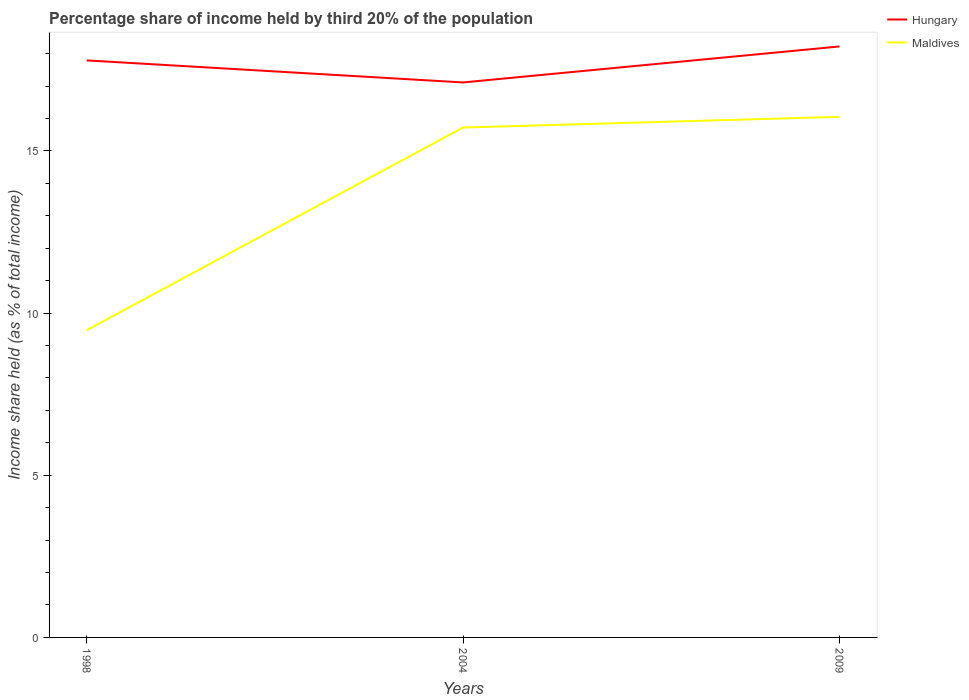How many different coloured lines are there?
Ensure brevity in your answer.  2. Does the line corresponding to Maldives intersect with the line corresponding to Hungary?
Make the answer very short. No. Across all years, what is the maximum share of income held by third 20% of the population in Maldives?
Make the answer very short. 9.47. In which year was the share of income held by third 20% of the population in Maldives maximum?
Keep it short and to the point. 1998. What is the total share of income held by third 20% of the population in Maldives in the graph?
Your answer should be very brief. -0.33. What is the difference between the highest and the second highest share of income held by third 20% of the population in Maldives?
Provide a succinct answer. 6.58. What is the difference between the highest and the lowest share of income held by third 20% of the population in Hungary?
Ensure brevity in your answer.  2. Is the share of income held by third 20% of the population in Hungary strictly greater than the share of income held by third 20% of the population in Maldives over the years?
Ensure brevity in your answer.  No. What is the difference between two consecutive major ticks on the Y-axis?
Offer a terse response. 5. Are the values on the major ticks of Y-axis written in scientific E-notation?
Make the answer very short. No. How many legend labels are there?
Offer a very short reply. 2. What is the title of the graph?
Give a very brief answer. Percentage share of income held by third 20% of the population. What is the label or title of the Y-axis?
Make the answer very short. Income share held (as % of total income). What is the Income share held (as % of total income) in Hungary in 1998?
Keep it short and to the point. 17.79. What is the Income share held (as % of total income) in Maldives in 1998?
Provide a succinct answer. 9.47. What is the Income share held (as % of total income) of Hungary in 2004?
Your answer should be compact. 17.11. What is the Income share held (as % of total income) of Maldives in 2004?
Offer a terse response. 15.72. What is the Income share held (as % of total income) in Hungary in 2009?
Give a very brief answer. 18.22. What is the Income share held (as % of total income) of Maldives in 2009?
Your answer should be compact. 16.05. Across all years, what is the maximum Income share held (as % of total income) in Hungary?
Ensure brevity in your answer.  18.22. Across all years, what is the maximum Income share held (as % of total income) in Maldives?
Provide a succinct answer. 16.05. Across all years, what is the minimum Income share held (as % of total income) of Hungary?
Offer a terse response. 17.11. Across all years, what is the minimum Income share held (as % of total income) of Maldives?
Provide a short and direct response. 9.47. What is the total Income share held (as % of total income) in Hungary in the graph?
Ensure brevity in your answer.  53.12. What is the total Income share held (as % of total income) of Maldives in the graph?
Provide a short and direct response. 41.24. What is the difference between the Income share held (as % of total income) of Hungary in 1998 and that in 2004?
Offer a very short reply. 0.68. What is the difference between the Income share held (as % of total income) of Maldives in 1998 and that in 2004?
Your answer should be compact. -6.25. What is the difference between the Income share held (as % of total income) of Hungary in 1998 and that in 2009?
Offer a very short reply. -0.43. What is the difference between the Income share held (as % of total income) of Maldives in 1998 and that in 2009?
Offer a very short reply. -6.58. What is the difference between the Income share held (as % of total income) of Hungary in 2004 and that in 2009?
Make the answer very short. -1.11. What is the difference between the Income share held (as % of total income) in Maldives in 2004 and that in 2009?
Offer a very short reply. -0.33. What is the difference between the Income share held (as % of total income) of Hungary in 1998 and the Income share held (as % of total income) of Maldives in 2004?
Offer a very short reply. 2.07. What is the difference between the Income share held (as % of total income) of Hungary in 1998 and the Income share held (as % of total income) of Maldives in 2009?
Keep it short and to the point. 1.74. What is the difference between the Income share held (as % of total income) of Hungary in 2004 and the Income share held (as % of total income) of Maldives in 2009?
Your response must be concise. 1.06. What is the average Income share held (as % of total income) of Hungary per year?
Offer a very short reply. 17.71. What is the average Income share held (as % of total income) in Maldives per year?
Ensure brevity in your answer.  13.75. In the year 1998, what is the difference between the Income share held (as % of total income) of Hungary and Income share held (as % of total income) of Maldives?
Your answer should be compact. 8.32. In the year 2004, what is the difference between the Income share held (as % of total income) of Hungary and Income share held (as % of total income) of Maldives?
Your answer should be very brief. 1.39. In the year 2009, what is the difference between the Income share held (as % of total income) of Hungary and Income share held (as % of total income) of Maldives?
Provide a succinct answer. 2.17. What is the ratio of the Income share held (as % of total income) in Hungary in 1998 to that in 2004?
Ensure brevity in your answer.  1.04. What is the ratio of the Income share held (as % of total income) of Maldives in 1998 to that in 2004?
Your answer should be compact. 0.6. What is the ratio of the Income share held (as % of total income) in Hungary in 1998 to that in 2009?
Your answer should be very brief. 0.98. What is the ratio of the Income share held (as % of total income) in Maldives in 1998 to that in 2009?
Ensure brevity in your answer.  0.59. What is the ratio of the Income share held (as % of total income) in Hungary in 2004 to that in 2009?
Keep it short and to the point. 0.94. What is the ratio of the Income share held (as % of total income) in Maldives in 2004 to that in 2009?
Provide a short and direct response. 0.98. What is the difference between the highest and the second highest Income share held (as % of total income) of Hungary?
Offer a very short reply. 0.43. What is the difference between the highest and the second highest Income share held (as % of total income) in Maldives?
Ensure brevity in your answer.  0.33. What is the difference between the highest and the lowest Income share held (as % of total income) of Hungary?
Keep it short and to the point. 1.11. What is the difference between the highest and the lowest Income share held (as % of total income) in Maldives?
Offer a very short reply. 6.58. 